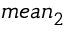<formula> <loc_0><loc_0><loc_500><loc_500>m e a n _ { 2 }</formula> 